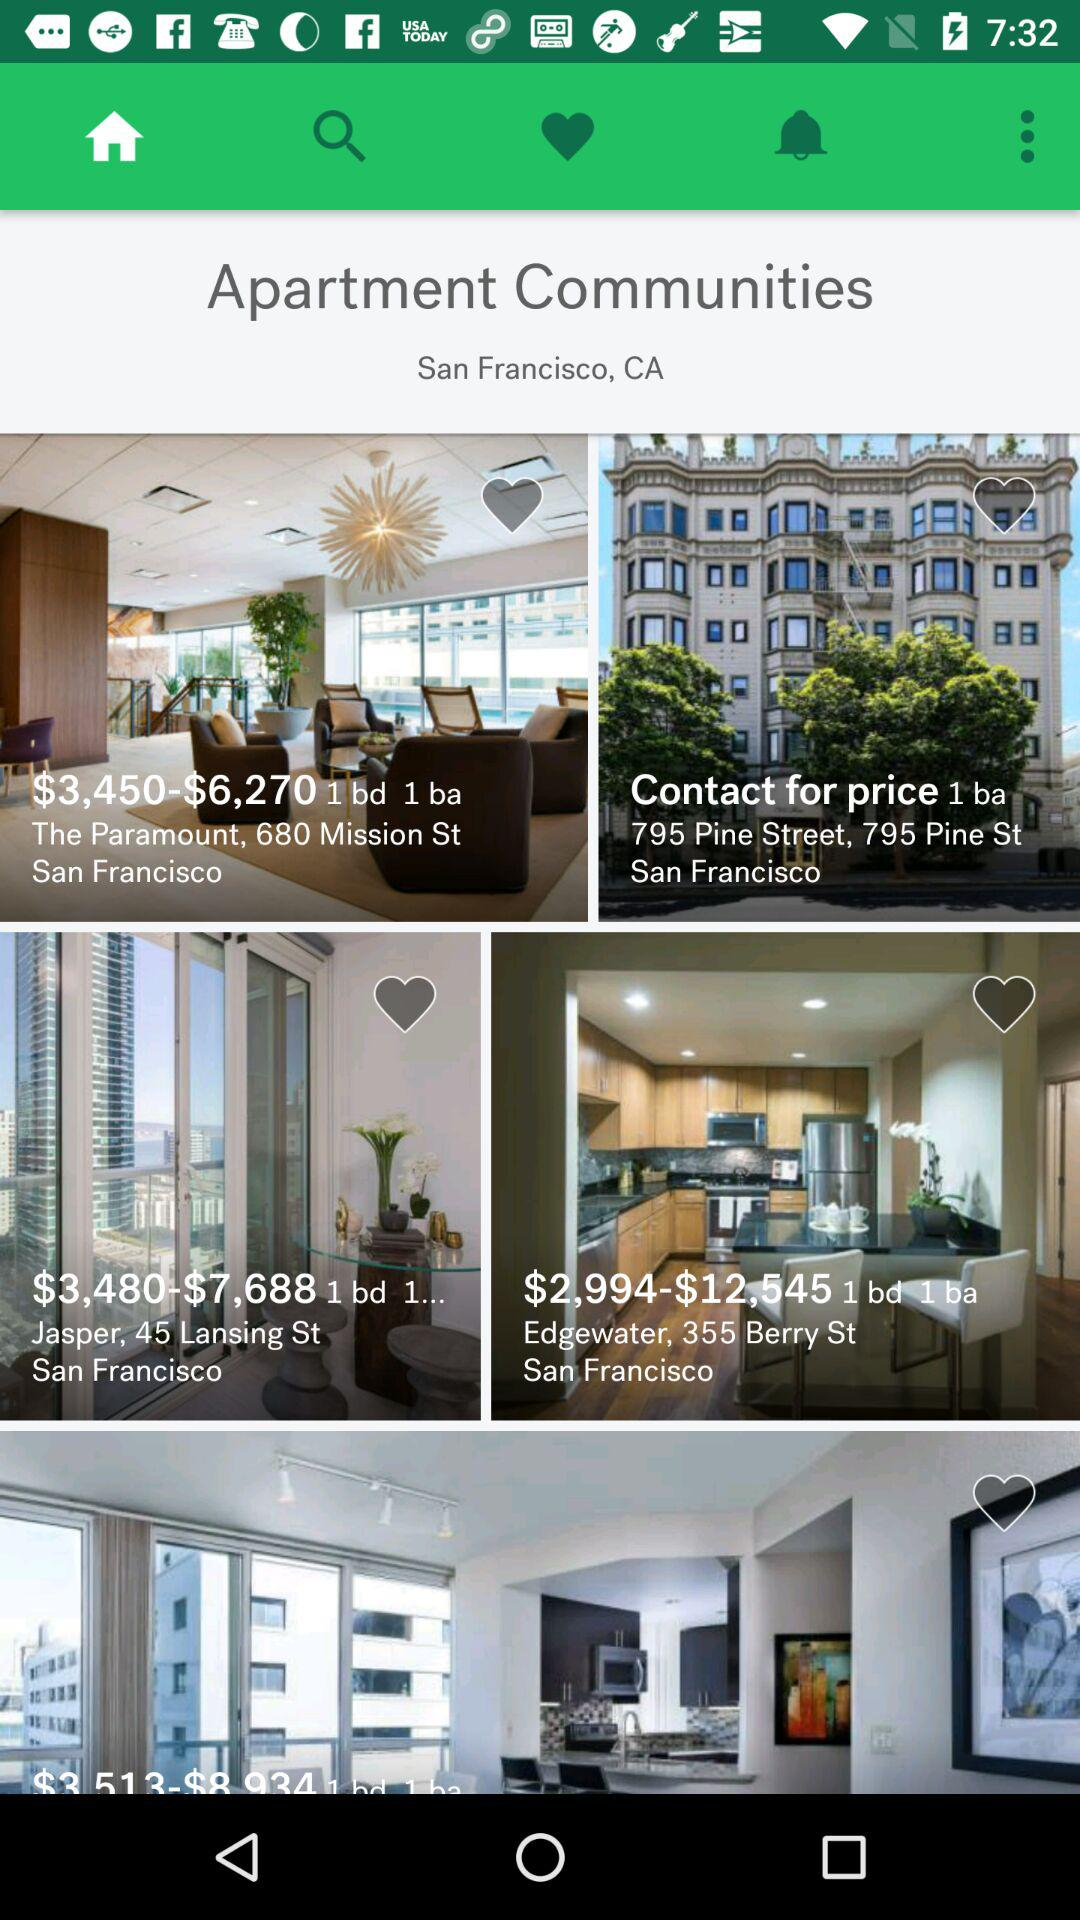Which apartments are liked?
When the provided information is insufficient, respond with <no answer>. <no answer> 